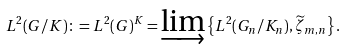Convert formula to latex. <formula><loc_0><loc_0><loc_500><loc_500>L ^ { 2 } ( G / K ) \colon = L ^ { 2 } ( G ) ^ { K } = \varinjlim \left \{ L ^ { 2 } ( G _ { n } / K _ { n } ) , \widetilde { \zeta } _ { m , n } \right \} .</formula> 